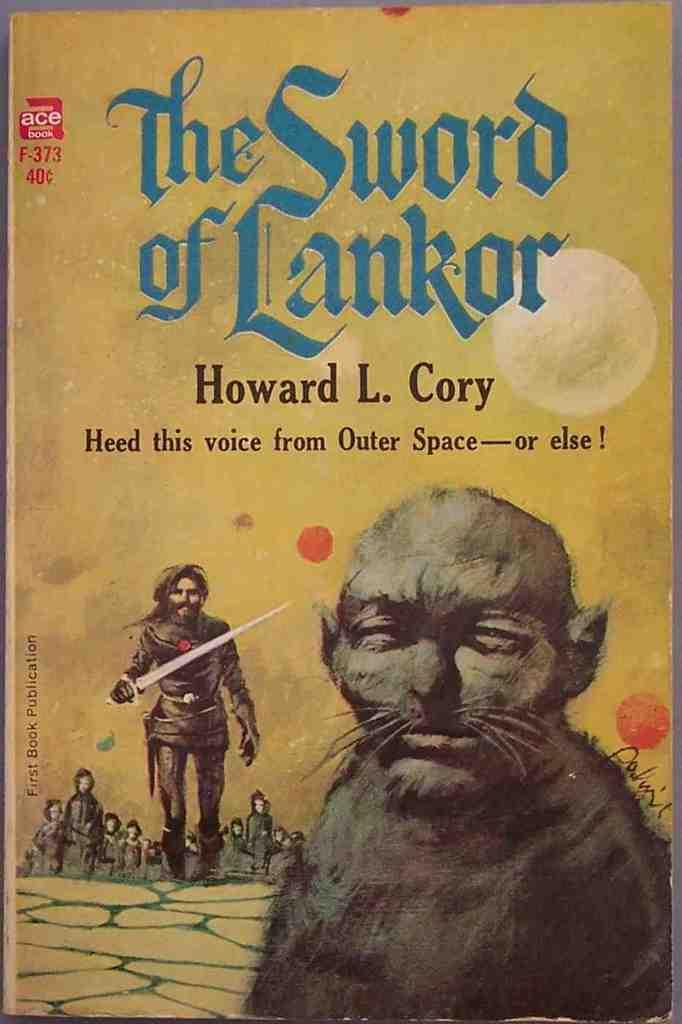<image>
Give a short and clear explanation of the subsequent image. A novel of The Sword of Lankor with a soldier and a unknown being. 